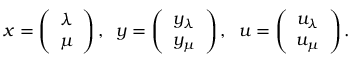Convert formula to latex. <formula><loc_0><loc_0><loc_500><loc_500>x = \left ( \begin{array} { c } { \lambda } \\ { \mu } \end{array} \right ) , \, y = \left ( \begin{array} { c } { y _ { \lambda } } \\ { y _ { \mu } } \end{array} \right ) , \, u = \left ( \begin{array} { c } { u _ { \lambda } } \\ { u _ { \mu } } \end{array} \right ) .</formula> 